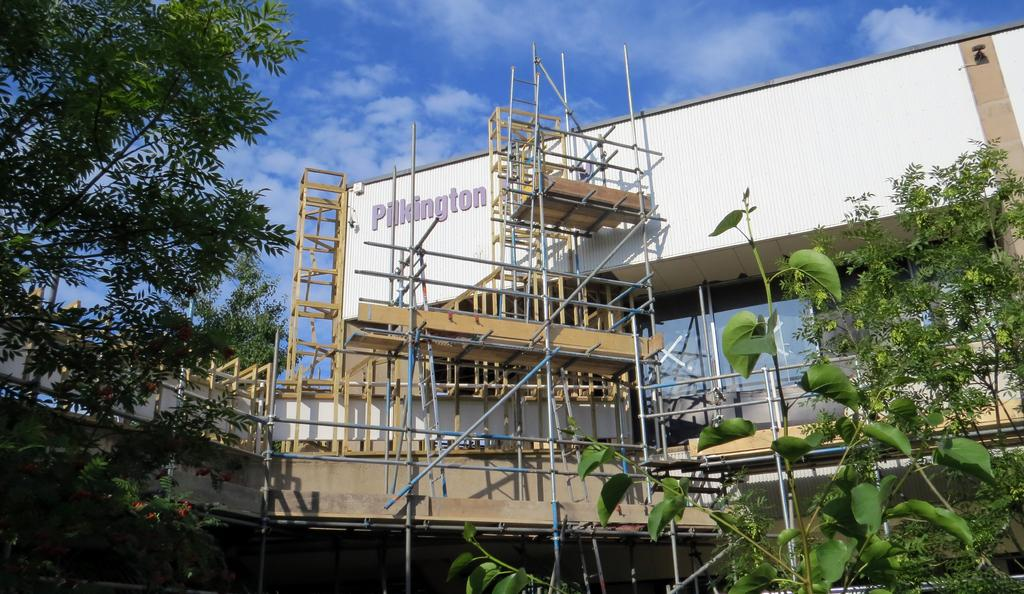What type of vegetation is on the left side of the image? There are trees on the left side of the image. What type of vegetation is on the right side of the image? There are trees on the right side of the image. What can be seen in the background of the image? A: There is a building and wooden ladders arranged in the background. What is the color of the sky in the image? The sky is blue with clouds visible. How does the image compare to a lumber yard? The image does not depict a lumber yard; it features trees, a building, wooden ladders, and a blue sky with clouds. What type of wash is being done in the image? There is no wash being done in the image; it shows trees, a building, wooden ladders, and a blue sky with clouds. 